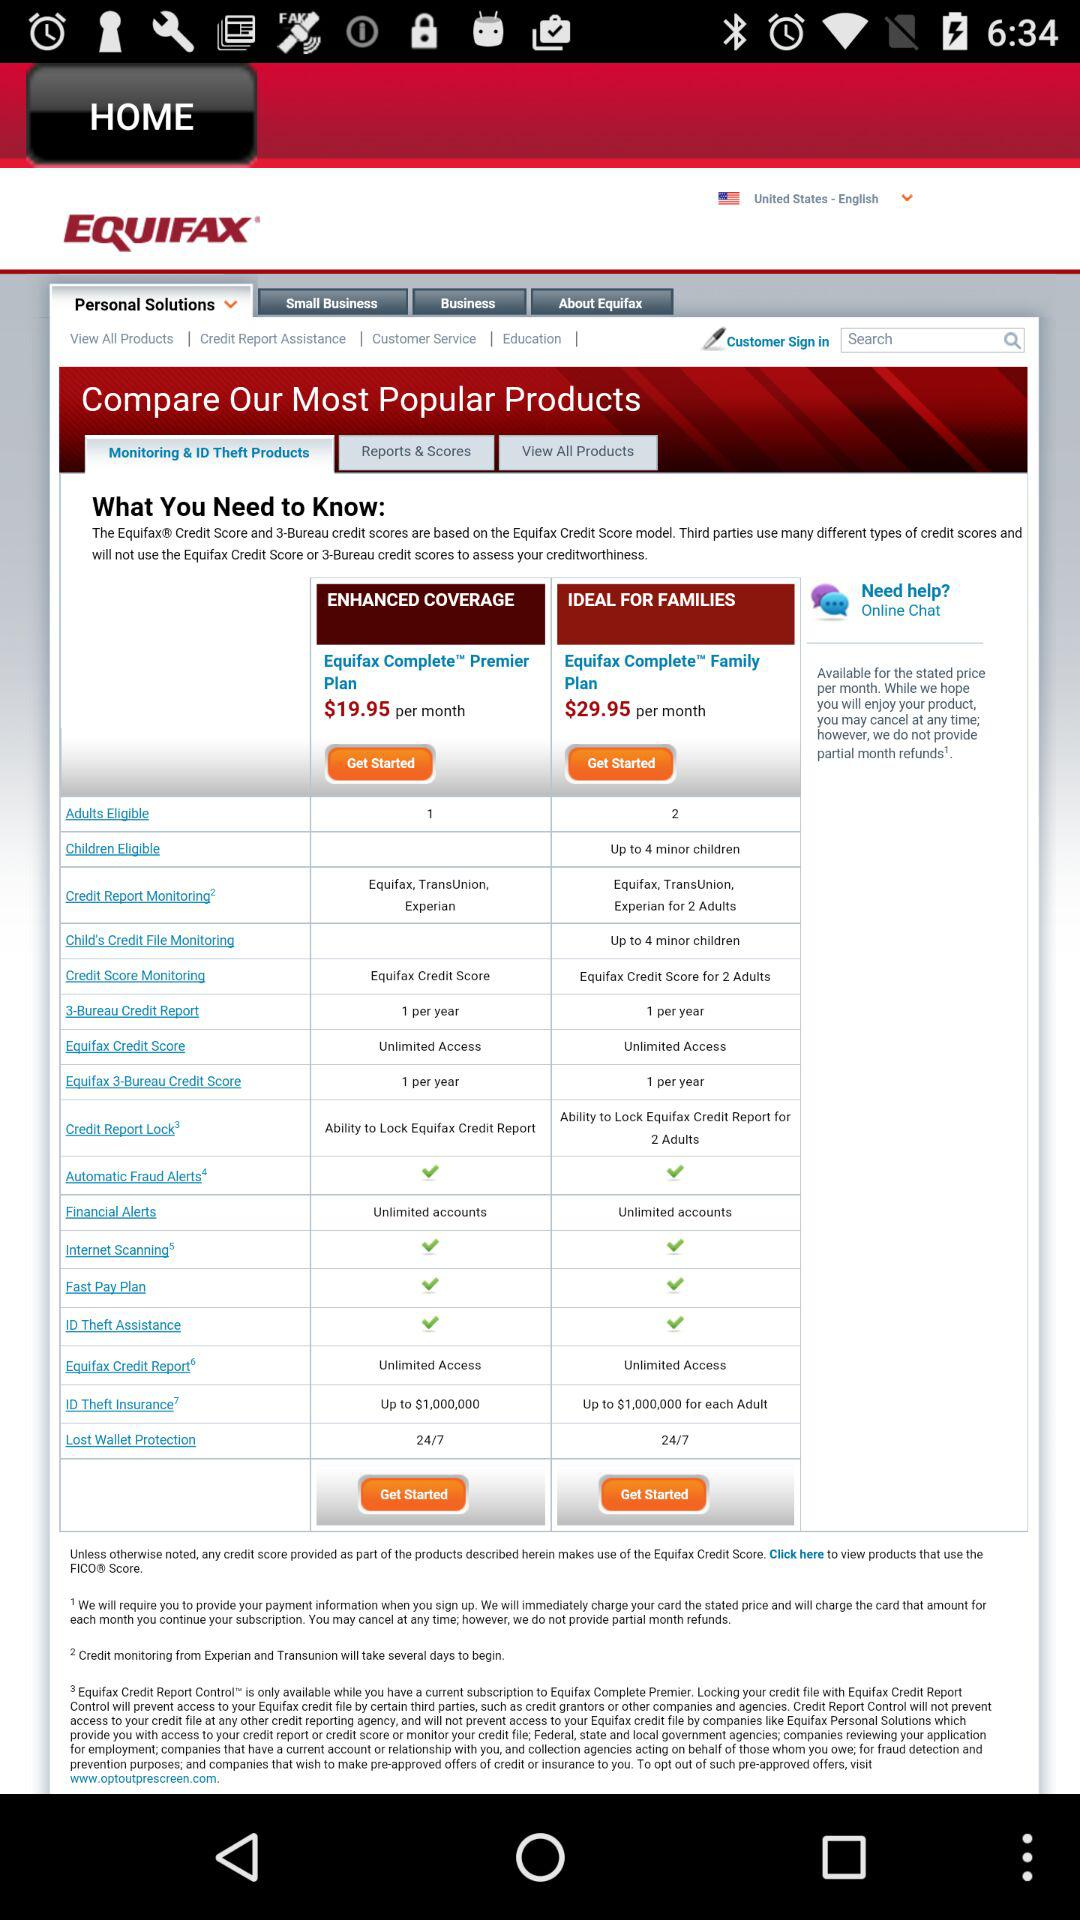What's the price of "Equifax Complete Family Plan"? The price is $29.95 per month. 